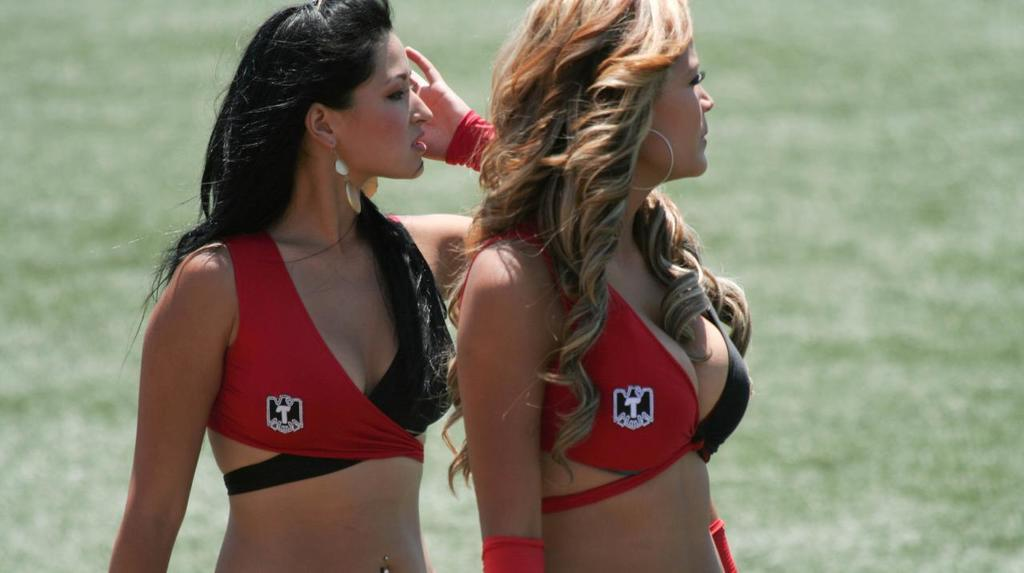Provide a one-sentence caption for the provided image. Two women wear tops that have the letter "T" on the right side. 